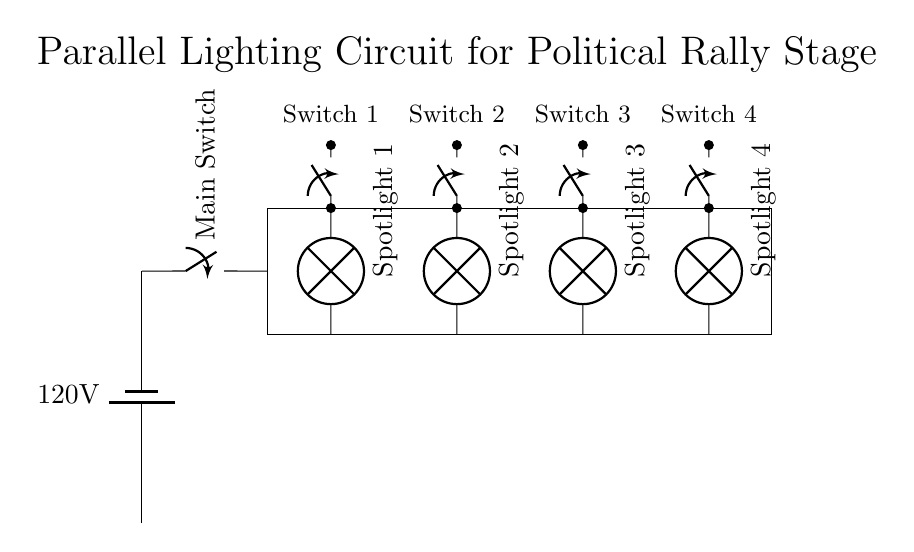What is the voltage of the circuit? The circuit is powered by a battery labeled 120V, which indicates the voltage supplied to the entire setup.
Answer: 120V How many spotlights are in the circuit? By visually inspecting the circuit diagram, there are four spotlights indicated, each connected in a parallel configuration.
Answer: Four What is the purpose of the main switch? The main switch controls the overall power supply to the lighting circuit, allowing the user to turn the entire setup on or off.
Answer: To control power Are the spotlights connected in series or parallel? The diagram shows that the spotlights are connected parallel to each other, allowing each spotlight to operate independently of the others.
Answer: Parallel What would happen if one spotlight fails? In a parallel circuit, if one spotlight fails, the others continue to receive the full voltage and remain operational, demonstrating reliability in lighting.
Answer: Others stay on What is indicated by the individual switches for each spotlight? The individual switches provide the ability to control each spotlight independently, allowing for greater flexibility in the lighting configuration during the rally.
Answer: Independent control 